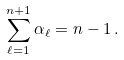<formula> <loc_0><loc_0><loc_500><loc_500>\sum _ { \ell = 1 } ^ { n + 1 } \alpha _ { \ell } = n - 1 \, .</formula> 